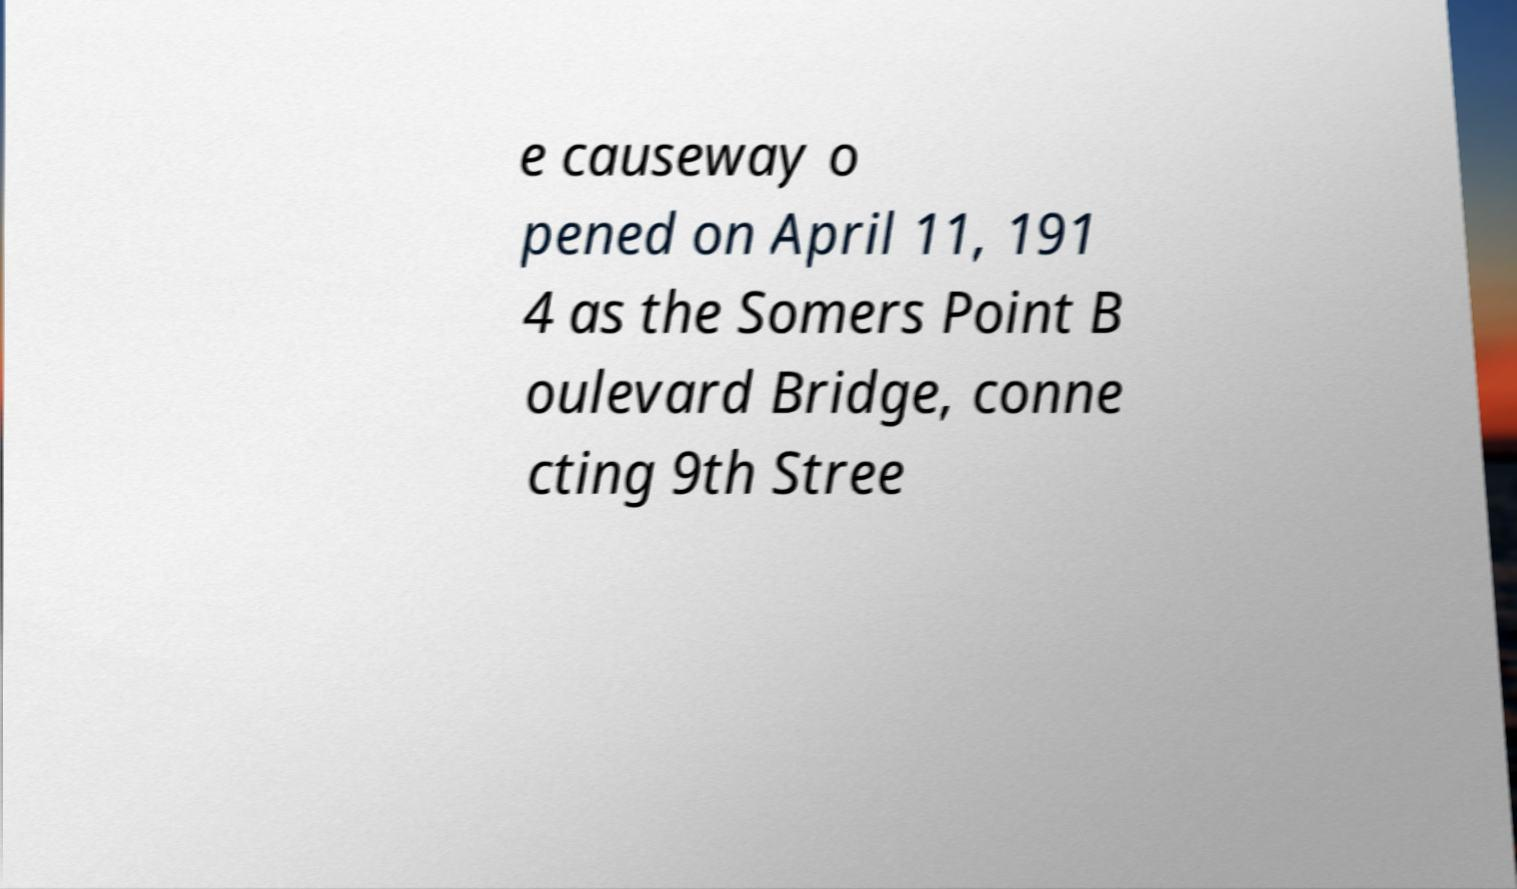Could you extract and type out the text from this image? e causeway o pened on April 11, 191 4 as the Somers Point B oulevard Bridge, conne cting 9th Stree 